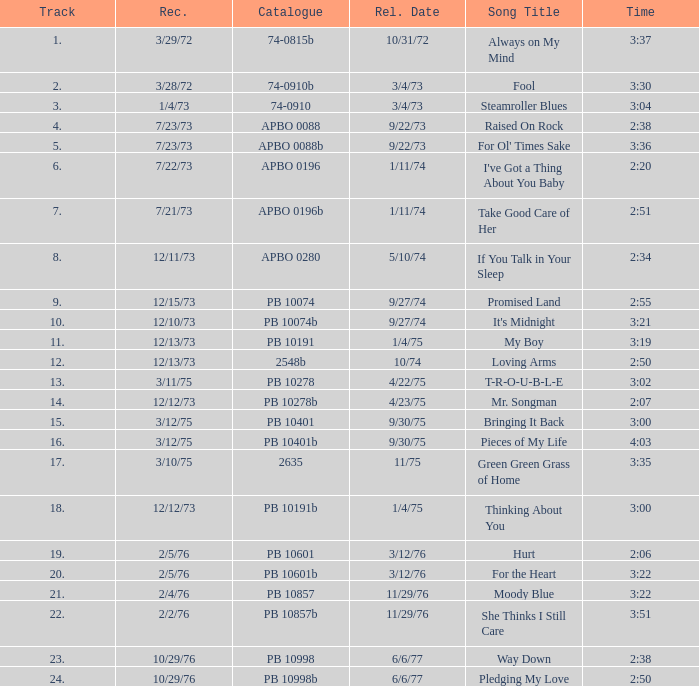I want the sum of tracks for raised on rock 4.0. 